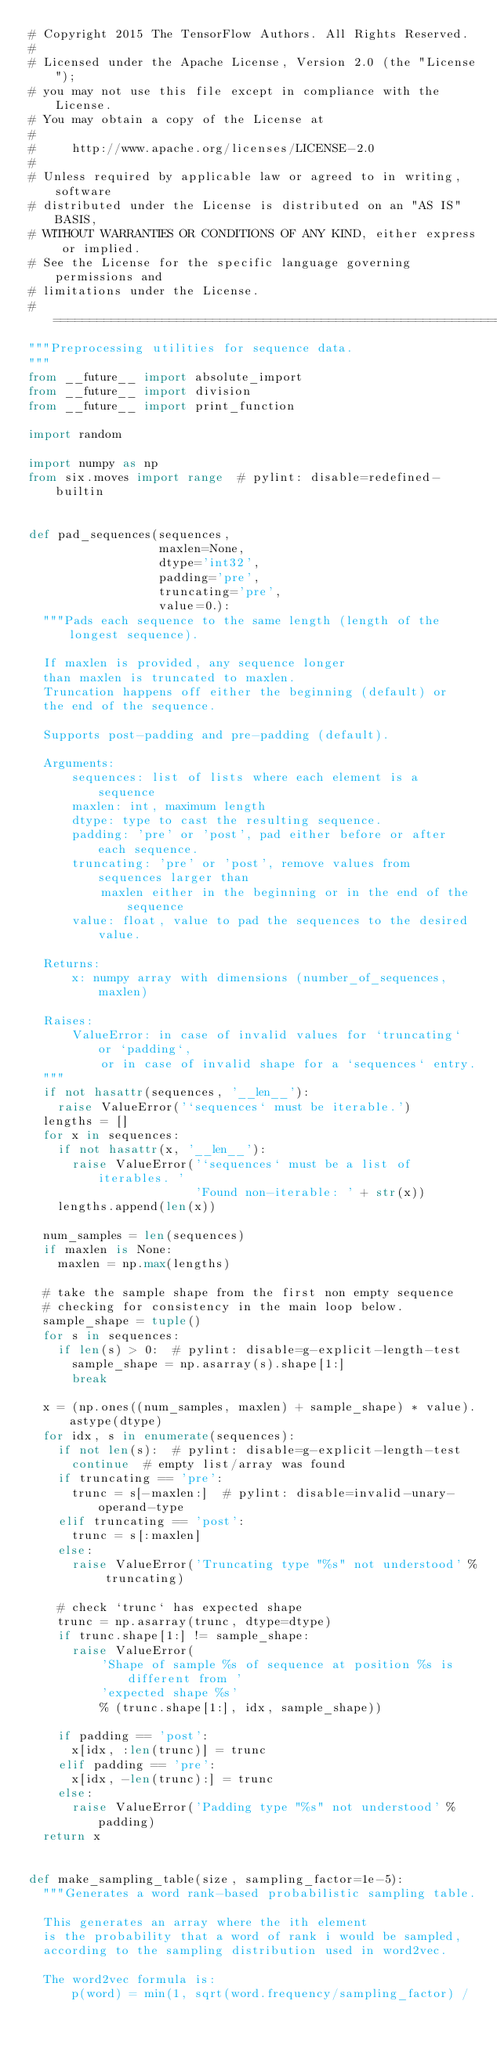<code> <loc_0><loc_0><loc_500><loc_500><_Python_># Copyright 2015 The TensorFlow Authors. All Rights Reserved.
#
# Licensed under the Apache License, Version 2.0 (the "License");
# you may not use this file except in compliance with the License.
# You may obtain a copy of the License at
#
#     http://www.apache.org/licenses/LICENSE-2.0
#
# Unless required by applicable law or agreed to in writing, software
# distributed under the License is distributed on an "AS IS" BASIS,
# WITHOUT WARRANTIES OR CONDITIONS OF ANY KIND, either express or implied.
# See the License for the specific language governing permissions and
# limitations under the License.
# ==============================================================================
"""Preprocessing utilities for sequence data.
"""
from __future__ import absolute_import
from __future__ import division
from __future__ import print_function

import random

import numpy as np
from six.moves import range  # pylint: disable=redefined-builtin


def pad_sequences(sequences,
                  maxlen=None,
                  dtype='int32',
                  padding='pre',
                  truncating='pre',
                  value=0.):
  """Pads each sequence to the same length (length of the longest sequence).

  If maxlen is provided, any sequence longer
  than maxlen is truncated to maxlen.
  Truncation happens off either the beginning (default) or
  the end of the sequence.

  Supports post-padding and pre-padding (default).

  Arguments:
      sequences: list of lists where each element is a sequence
      maxlen: int, maximum length
      dtype: type to cast the resulting sequence.
      padding: 'pre' or 'post', pad either before or after each sequence.
      truncating: 'pre' or 'post', remove values from sequences larger than
          maxlen either in the beginning or in the end of the sequence
      value: float, value to pad the sequences to the desired value.

  Returns:
      x: numpy array with dimensions (number_of_sequences, maxlen)

  Raises:
      ValueError: in case of invalid values for `truncating` or `padding`,
          or in case of invalid shape for a `sequences` entry.
  """
  if not hasattr(sequences, '__len__'):
    raise ValueError('`sequences` must be iterable.')
  lengths = []
  for x in sequences:
    if not hasattr(x, '__len__'):
      raise ValueError('`sequences` must be a list of iterables. '
                       'Found non-iterable: ' + str(x))
    lengths.append(len(x))

  num_samples = len(sequences)
  if maxlen is None:
    maxlen = np.max(lengths)

  # take the sample shape from the first non empty sequence
  # checking for consistency in the main loop below.
  sample_shape = tuple()
  for s in sequences:
    if len(s) > 0:  # pylint: disable=g-explicit-length-test
      sample_shape = np.asarray(s).shape[1:]
      break

  x = (np.ones((num_samples, maxlen) + sample_shape) * value).astype(dtype)
  for idx, s in enumerate(sequences):
    if not len(s):  # pylint: disable=g-explicit-length-test
      continue  # empty list/array was found
    if truncating == 'pre':
      trunc = s[-maxlen:]  # pylint: disable=invalid-unary-operand-type
    elif truncating == 'post':
      trunc = s[:maxlen]
    else:
      raise ValueError('Truncating type "%s" not understood' % truncating)

    # check `trunc` has expected shape
    trunc = np.asarray(trunc, dtype=dtype)
    if trunc.shape[1:] != sample_shape:
      raise ValueError(
          'Shape of sample %s of sequence at position %s is different from '
          'expected shape %s'
          % (trunc.shape[1:], idx, sample_shape))

    if padding == 'post':
      x[idx, :len(trunc)] = trunc
    elif padding == 'pre':
      x[idx, -len(trunc):] = trunc
    else:
      raise ValueError('Padding type "%s" not understood' % padding)
  return x


def make_sampling_table(size, sampling_factor=1e-5):
  """Generates a word rank-based probabilistic sampling table.

  This generates an array where the ith element
  is the probability that a word of rank i would be sampled,
  according to the sampling distribution used in word2vec.

  The word2vec formula is:
      p(word) = min(1, sqrt(word.frequency/sampling_factor) /</code> 